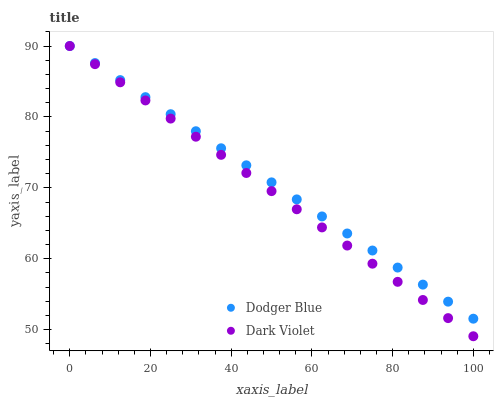Does Dark Violet have the minimum area under the curve?
Answer yes or no. Yes. Does Dodger Blue have the maximum area under the curve?
Answer yes or no. Yes. Does Dark Violet have the maximum area under the curve?
Answer yes or no. No. Is Dodger Blue the smoothest?
Answer yes or no. Yes. Is Dark Violet the roughest?
Answer yes or no. Yes. Is Dark Violet the smoothest?
Answer yes or no. No. Does Dark Violet have the lowest value?
Answer yes or no. Yes. Does Dark Violet have the highest value?
Answer yes or no. Yes. Does Dodger Blue intersect Dark Violet?
Answer yes or no. Yes. Is Dodger Blue less than Dark Violet?
Answer yes or no. No. Is Dodger Blue greater than Dark Violet?
Answer yes or no. No. 